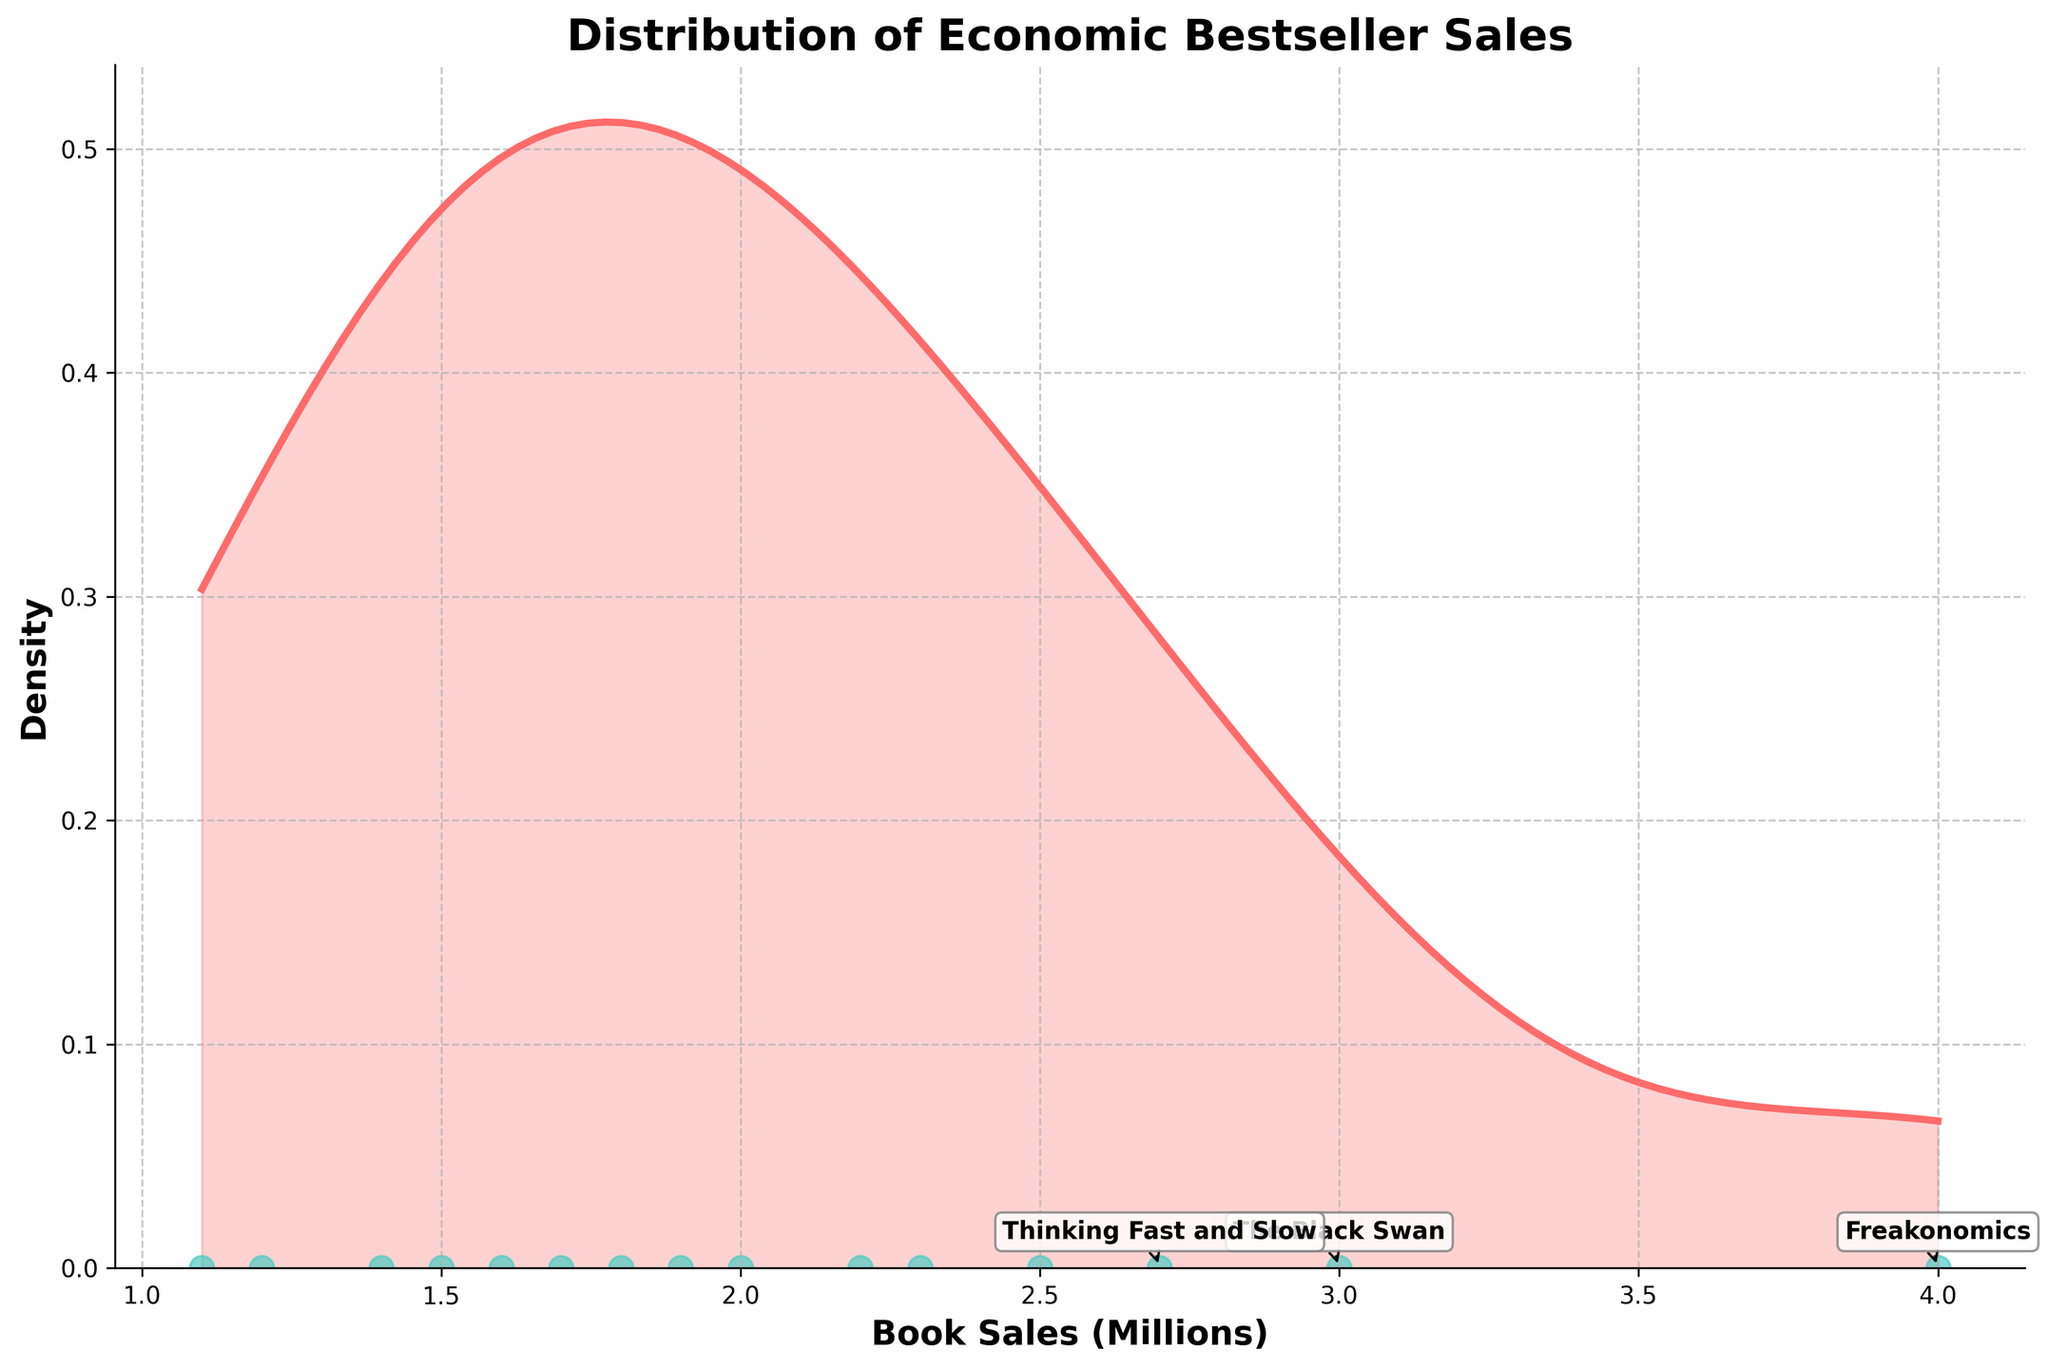What is the title of the plot? The title of the plot is indicated at the top of the figure. It reads 'Distribution of Economic Bestseller Sales'.
Answer: Distribution of Economic Bestseller Sales How many books have sales between 1.5 and 2.5 million copies? By looking at the scatter plot below the density curve, count the data points positioned between 1.5 and 2.5 on the x-axis. There are six data points.
Answer: 6 Which book has the highest sales? The top 3 bestsellers are annotated on the plot. The highest sales, `Freakonomics`, is found at the top position with 4 million copies sold.
Answer: Freakonomics How does the density of sales above 3 million compare to the density below 2 million? The plot shows that there is a higher density of sales below 2 million as indicated by the peak of the curve, compared to the smaller density in the area above 3 million, where the curve is lower.
Answer: Higher density below 2 million What's the median value of book sales? Identify the middle value of the ordered data set. Sorting the books by sales reveals the middle value is `The Big Short` with sales approximately 1.8 million copies.
Answer: 1.8 million Which book had sales closest to 2 million? By examining the scatter plot, `Predictably Irrational` is the book closest to the 2 million sales mark.
Answer: Predictably Irrational Are there more books with sales above or below 2 million? Count the data points above and below the 2 million mark on the scatter plot. There are five books above and nine books below 2 million.
Answer: Below 2 million What is the y-axis label on the plot? The y-axis label is found on the vertical axis of the figure. It reads 'Density'.
Answer: Density What color is used to highlight the density curve and the data points on the plot? The density curve is a shade of red while the data points are highlighted in a cyan color.
Answer: Red and cyan Is the density plot skewed to the right or left? By observing the shape of the density curve, it extends further to the right, indicating it is right-skewed.
Answer: Right-skewed 